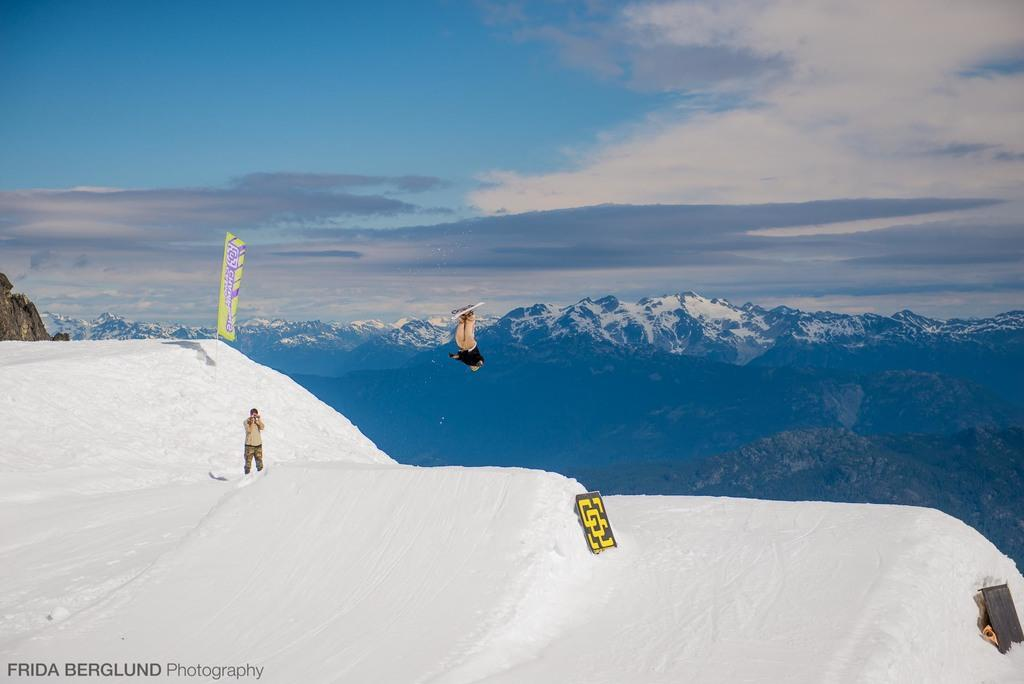What type of natural formation can be seen in the image? There are mountains in the image. What is hanging or attached in the image? There is a banner in the image. What objects are present in the image that are flat and rigid? There are boards in the image. What is the weather like in the image? There is snow visible in the image, which suggests a cold or snowy environment. How many people are in the image? One person is standing and one person is in the air in the image. What is the color of the sky in the image? The sky is blue and white in color. What type of beam is being polished by the person in the image? There is no beam or polishing activity present in the image. What level of difficulty is the person in the air attempting to achieve? There is no indication of difficulty levels or challenges in the image; the person is simply in the air. 